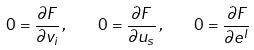<formula> <loc_0><loc_0><loc_500><loc_500>0 = \frac { \partial F } { \partial v _ { i } } \, , \quad 0 = \frac { \partial F } { \partial u _ { s } } \, , \quad 0 = \frac { \partial F } { \partial e ^ { I } }</formula> 